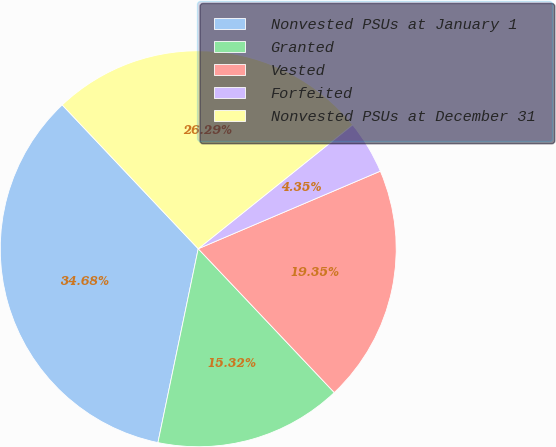Convert chart to OTSL. <chart><loc_0><loc_0><loc_500><loc_500><pie_chart><fcel>Nonvested PSUs at January 1<fcel>Granted<fcel>Vested<fcel>Forfeited<fcel>Nonvested PSUs at December 31<nl><fcel>34.68%<fcel>15.32%<fcel>19.35%<fcel>4.35%<fcel>26.29%<nl></chart> 